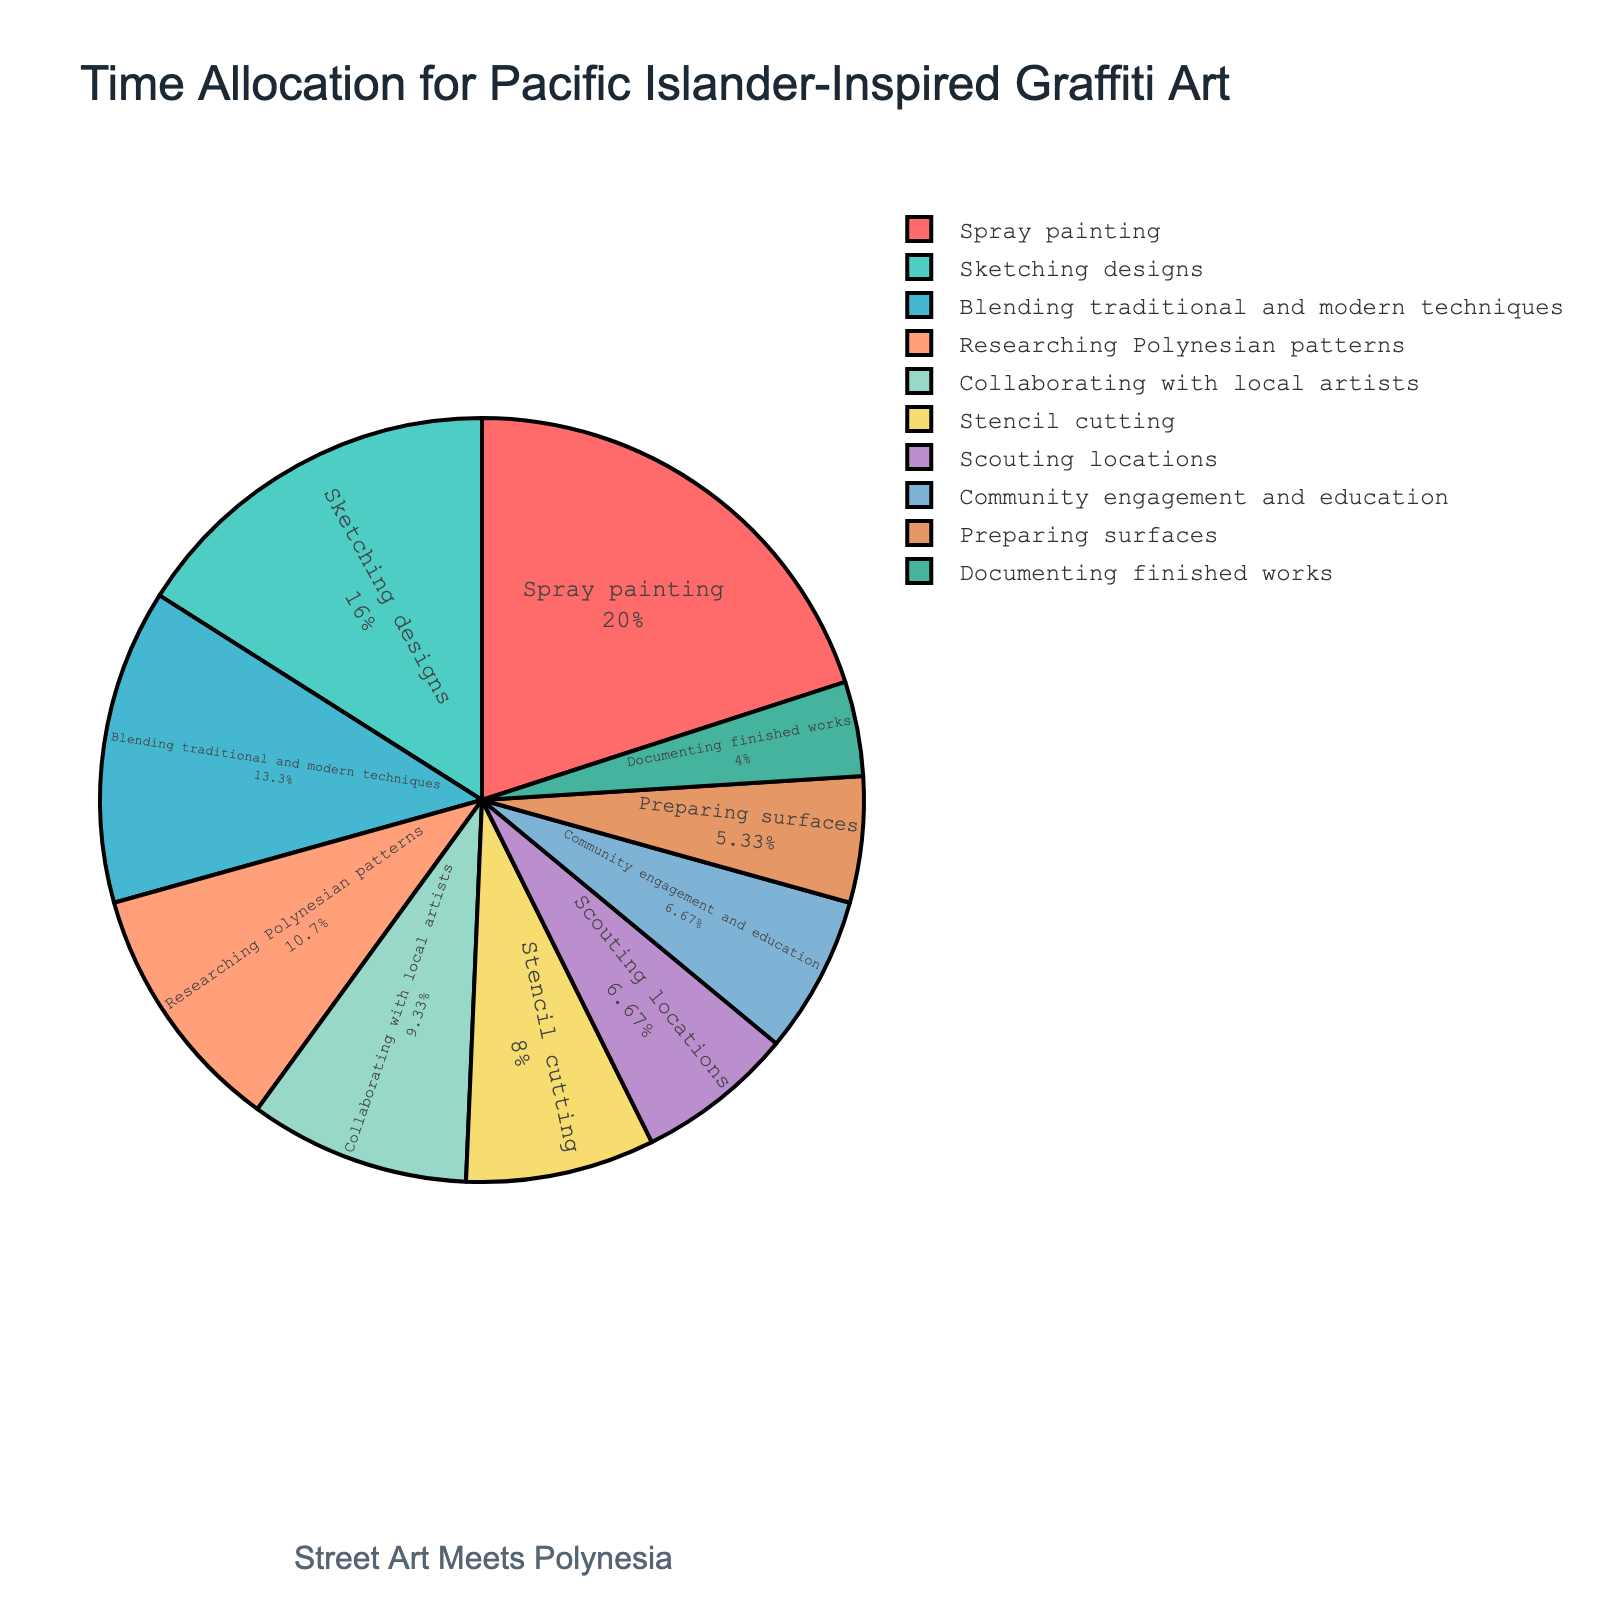What activity takes up the most time? Refer to the pie chart and look for the largest section. The largest section corresponds to "Spray painting" with 15 hours.
Answer: Spray painting How much time is spent on "Sketching designs" and "Researching Polynesian patterns" combined? Find the sections for "Sketching designs" and "Researching Polynesian patterns". Add their times together: 12 hours + 8 hours = 20 hours.
Answer: 20 hours Which activities take equal amounts of time? Look for sections of the pie chart with equal sizes. "Scouting locations" and "Community engagement and education" both have 5 hours.
Answer: Scouting locations and Community engagement and education What percentage of time is spent on "Blending traditional and modern techniques"? Locate the section for "Blending traditional and modern techniques". Calculate the percentage: (10 hours / 75 hours total) * 100 ≈ 13.33%.
Answer: Roughly 13.33% How much more time is spent on "Spray painting" than "Stencil cutting"? Find the sections for "Spray painting" and "Stencil cutting". Subtract the time for "Stencil cutting" from "Spray painting": 15 hours - 6 hours = 9 hours.
Answer: 9 hours Which activity is represented by the color green? Refer to the color green in the pie chart. The green section represents "Researching Polynesian patterns".
Answer: Researching Polynesian patterns Rank the activities from most time-consuming to least time-consuming. List all activities by their hours in descending order: Spray painting (15), Sketching designs (12), Blending traditional and modern techniques (10), Researching Polynesian patterns (8), Collaborating with local artists (7), Stencil cutting (6), Scouting locations (5), Community engagement and education (5), Preparing surfaces (4), Documenting finished works (3).
Answer: Spray painting, Sketching designs, Blending traditional and modern techniques, Researching Polynesian patterns, Collaborating with local artists, Stencil cutting, Scouting locations, Community engagement and education, Preparing surfaces, Documenting finished works How much time is spent on preparatory activities like "Preparing surfaces" and "Stencil cutting" together? Sum the time spent on "Preparing surfaces" and "Stencil cutting": 4 hours + 6 hours = 10 hours.
Answer: 10 hours What fraction of the total time is spent on "Collaborating with local artists"? Calculate the fraction: 7 hours / 75 hours total. Simplify the fraction if possible: 7/75 ≈ 1/10.7, which can be simplified to approximately 1/11.
Answer: 1/11 Are there more hours spent on "Community engagement and education" or "Scouting locations"? Compare the hours: both "Community engagement and education" and "Scouting locations" have 5 hours each.
Answer: They are equal 